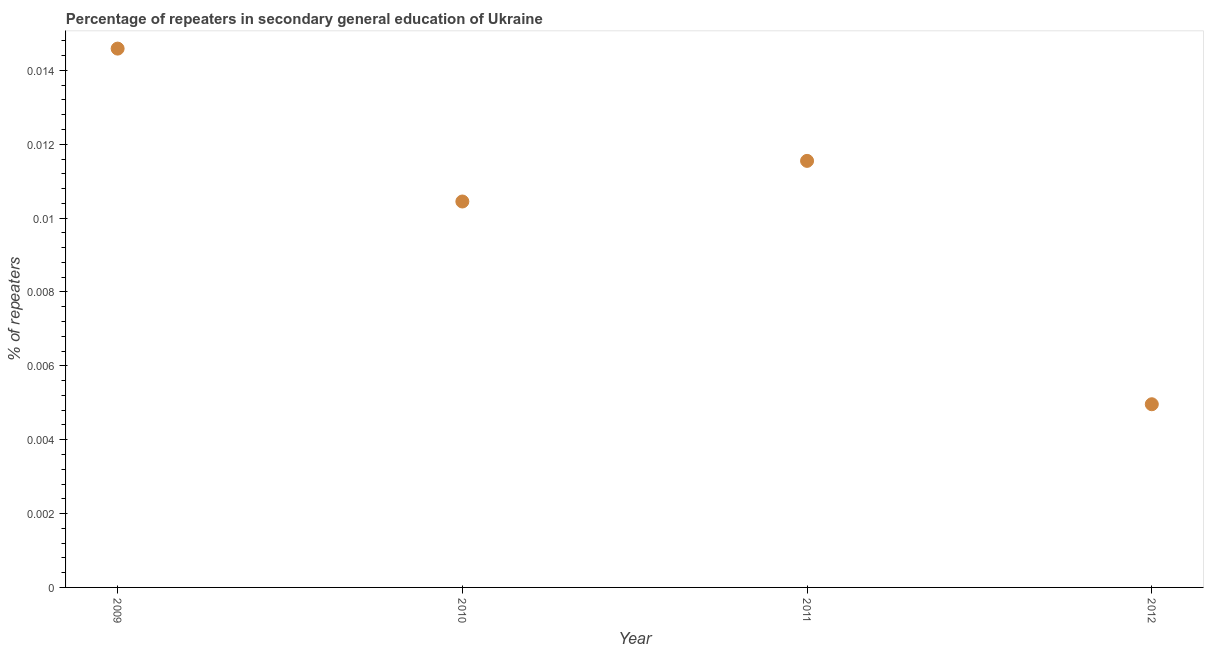What is the percentage of repeaters in 2011?
Your answer should be compact. 0.01. Across all years, what is the maximum percentage of repeaters?
Make the answer very short. 0.01. Across all years, what is the minimum percentage of repeaters?
Your response must be concise. 0. In which year was the percentage of repeaters maximum?
Provide a short and direct response. 2009. What is the sum of the percentage of repeaters?
Keep it short and to the point. 0.04. What is the difference between the percentage of repeaters in 2009 and 2012?
Give a very brief answer. 0.01. What is the average percentage of repeaters per year?
Offer a terse response. 0.01. What is the median percentage of repeaters?
Provide a succinct answer. 0.01. What is the ratio of the percentage of repeaters in 2009 to that in 2012?
Make the answer very short. 2.94. Is the difference between the percentage of repeaters in 2009 and 2012 greater than the difference between any two years?
Make the answer very short. Yes. What is the difference between the highest and the second highest percentage of repeaters?
Keep it short and to the point. 0. What is the difference between the highest and the lowest percentage of repeaters?
Offer a very short reply. 0.01. Does the percentage of repeaters monotonically increase over the years?
Offer a very short reply. No. How many years are there in the graph?
Your answer should be very brief. 4. What is the difference between two consecutive major ticks on the Y-axis?
Ensure brevity in your answer.  0. What is the title of the graph?
Your response must be concise. Percentage of repeaters in secondary general education of Ukraine. What is the label or title of the X-axis?
Your answer should be compact. Year. What is the label or title of the Y-axis?
Your response must be concise. % of repeaters. What is the % of repeaters in 2009?
Offer a very short reply. 0.01. What is the % of repeaters in 2010?
Offer a very short reply. 0.01. What is the % of repeaters in 2011?
Offer a terse response. 0.01. What is the % of repeaters in 2012?
Provide a short and direct response. 0. What is the difference between the % of repeaters in 2009 and 2010?
Your response must be concise. 0. What is the difference between the % of repeaters in 2009 and 2011?
Offer a very short reply. 0. What is the difference between the % of repeaters in 2009 and 2012?
Give a very brief answer. 0.01. What is the difference between the % of repeaters in 2010 and 2011?
Your answer should be compact. -0. What is the difference between the % of repeaters in 2010 and 2012?
Ensure brevity in your answer.  0.01. What is the difference between the % of repeaters in 2011 and 2012?
Your answer should be very brief. 0.01. What is the ratio of the % of repeaters in 2009 to that in 2010?
Give a very brief answer. 1.4. What is the ratio of the % of repeaters in 2009 to that in 2011?
Offer a terse response. 1.26. What is the ratio of the % of repeaters in 2009 to that in 2012?
Provide a succinct answer. 2.94. What is the ratio of the % of repeaters in 2010 to that in 2011?
Make the answer very short. 0.91. What is the ratio of the % of repeaters in 2010 to that in 2012?
Ensure brevity in your answer.  2.11. What is the ratio of the % of repeaters in 2011 to that in 2012?
Give a very brief answer. 2.33. 